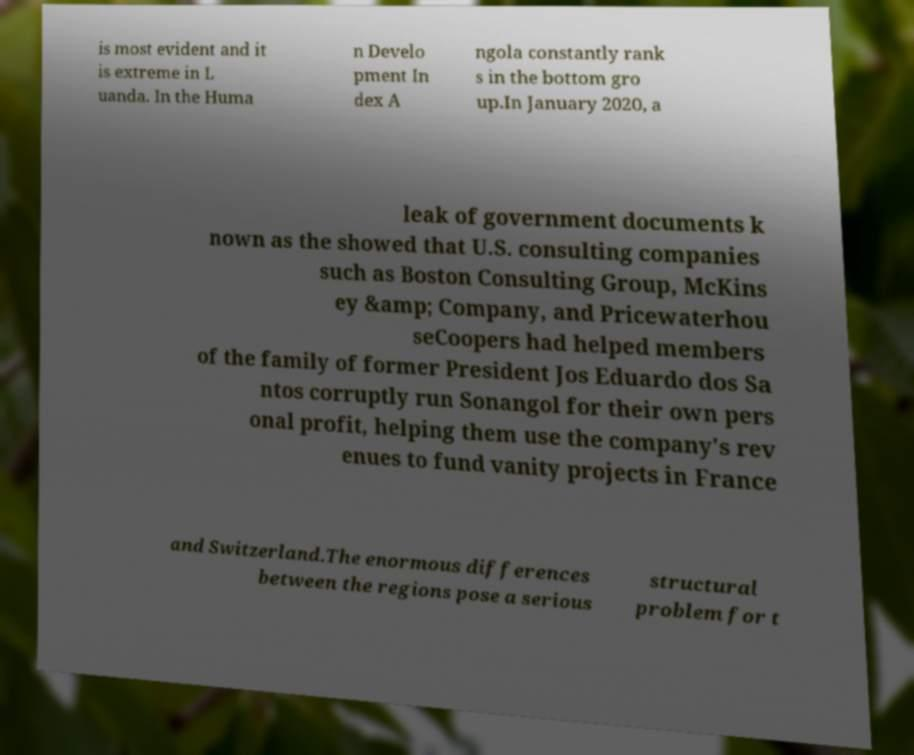Could you extract and type out the text from this image? is most evident and it is extreme in L uanda. In the Huma n Develo pment In dex A ngola constantly rank s in the bottom gro up.In January 2020, a leak of government documents k nown as the showed that U.S. consulting companies such as Boston Consulting Group, McKins ey &amp; Company, and Pricewaterhou seCoopers had helped members of the family of former President Jos Eduardo dos Sa ntos corruptly run Sonangol for their own pers onal profit, helping them use the company's rev enues to fund vanity projects in France and Switzerland.The enormous differences between the regions pose a serious structural problem for t 